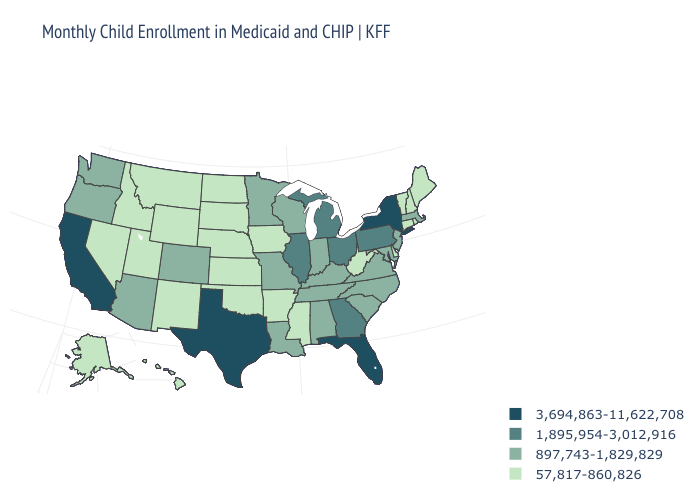Which states have the lowest value in the South?
Write a very short answer. Arkansas, Delaware, Mississippi, Oklahoma, West Virginia. What is the value of New Mexico?
Be succinct. 57,817-860,826. Does Virginia have the lowest value in the South?
Keep it brief. No. Name the states that have a value in the range 897,743-1,829,829?
Short answer required. Alabama, Arizona, Colorado, Indiana, Kentucky, Louisiana, Maryland, Massachusetts, Minnesota, Missouri, New Jersey, North Carolina, Oregon, South Carolina, Tennessee, Virginia, Washington, Wisconsin. Does the first symbol in the legend represent the smallest category?
Write a very short answer. No. Name the states that have a value in the range 3,694,863-11,622,708?
Keep it brief. California, Florida, New York, Texas. Name the states that have a value in the range 3,694,863-11,622,708?
Concise answer only. California, Florida, New York, Texas. Which states have the lowest value in the USA?
Write a very short answer. Alaska, Arkansas, Connecticut, Delaware, Hawaii, Idaho, Iowa, Kansas, Maine, Mississippi, Montana, Nebraska, Nevada, New Hampshire, New Mexico, North Dakota, Oklahoma, Rhode Island, South Dakota, Utah, Vermont, West Virginia, Wyoming. Among the states that border Nebraska , does Colorado have the lowest value?
Keep it brief. No. What is the value of Wisconsin?
Concise answer only. 897,743-1,829,829. Among the states that border Tennessee , which have the lowest value?
Concise answer only. Arkansas, Mississippi. What is the value of New York?
Concise answer only. 3,694,863-11,622,708. What is the value of South Carolina?
Write a very short answer. 897,743-1,829,829. What is the value of Georgia?
Concise answer only. 1,895,954-3,012,916. Does Colorado have the lowest value in the USA?
Give a very brief answer. No. 